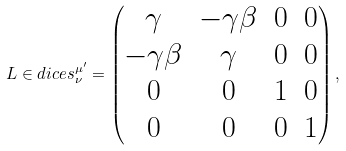<formula> <loc_0><loc_0><loc_500><loc_500>L \in d i c e s { ^ { \mu ^ { \prime } } _ { \nu } } = \begin{pmatrix} \gamma & - \gamma \beta & 0 & 0 \\ - \gamma \beta & \gamma & 0 & 0 \\ 0 & 0 & 1 & 0 \\ 0 & 0 & 0 & 1 \end{pmatrix} ,</formula> 